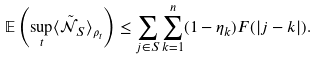<formula> <loc_0><loc_0><loc_500><loc_500>\mathbb { E } \left ( \sup _ { t } \langle \tilde { \mathcal { N } } _ { S } \rangle _ { \rho _ { t } } \right ) \leq \sum _ { j \in S } \sum _ { k = 1 } ^ { n } ( 1 - \eta _ { k } ) F ( | j - k | ) .</formula> 